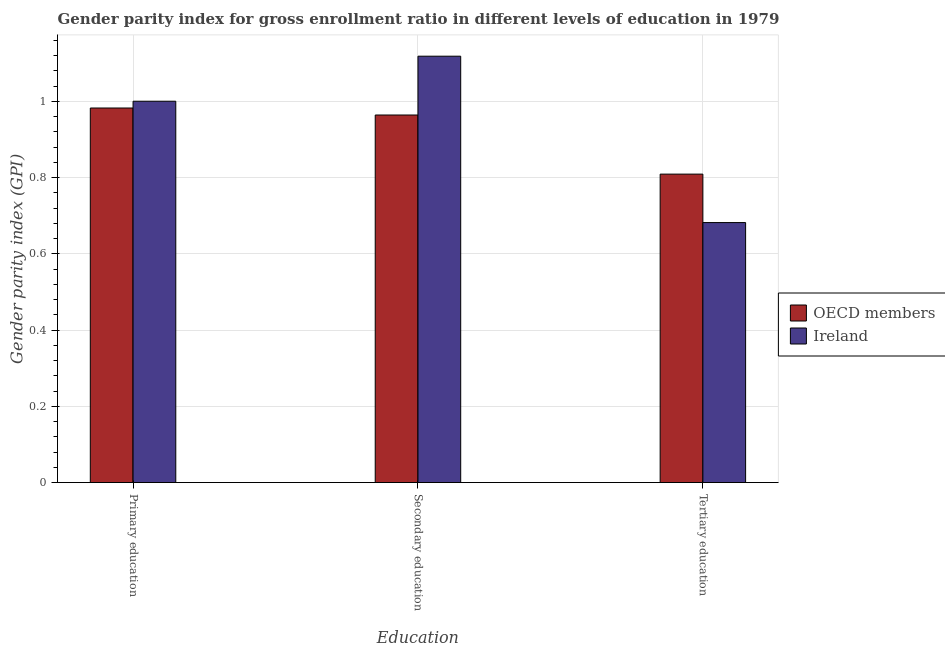Are the number of bars on each tick of the X-axis equal?
Give a very brief answer. Yes. How many bars are there on the 2nd tick from the right?
Provide a succinct answer. 2. What is the label of the 1st group of bars from the left?
Keep it short and to the point. Primary education. What is the gender parity index in tertiary education in Ireland?
Your response must be concise. 0.68. Across all countries, what is the maximum gender parity index in primary education?
Offer a terse response. 1. Across all countries, what is the minimum gender parity index in secondary education?
Provide a short and direct response. 0.96. In which country was the gender parity index in tertiary education maximum?
Give a very brief answer. OECD members. In which country was the gender parity index in secondary education minimum?
Keep it short and to the point. OECD members. What is the total gender parity index in primary education in the graph?
Offer a terse response. 1.98. What is the difference between the gender parity index in secondary education in Ireland and that in OECD members?
Your answer should be compact. 0.15. What is the difference between the gender parity index in primary education in Ireland and the gender parity index in tertiary education in OECD members?
Give a very brief answer. 0.19. What is the average gender parity index in secondary education per country?
Your answer should be compact. 1.04. What is the difference between the gender parity index in secondary education and gender parity index in tertiary education in OECD members?
Offer a very short reply. 0.16. In how many countries, is the gender parity index in secondary education greater than 0.7200000000000001 ?
Your answer should be compact. 2. What is the ratio of the gender parity index in secondary education in OECD members to that in Ireland?
Make the answer very short. 0.86. Is the gender parity index in tertiary education in OECD members less than that in Ireland?
Provide a short and direct response. No. What is the difference between the highest and the second highest gender parity index in primary education?
Your answer should be compact. 0.02. What is the difference between the highest and the lowest gender parity index in primary education?
Provide a succinct answer. 0.02. What does the 2nd bar from the left in Primary education represents?
Provide a short and direct response. Ireland. What does the 1st bar from the right in Primary education represents?
Provide a succinct answer. Ireland. Is it the case that in every country, the sum of the gender parity index in primary education and gender parity index in secondary education is greater than the gender parity index in tertiary education?
Make the answer very short. Yes. Are all the bars in the graph horizontal?
Your answer should be very brief. No. What is the difference between two consecutive major ticks on the Y-axis?
Provide a short and direct response. 0.2. Are the values on the major ticks of Y-axis written in scientific E-notation?
Ensure brevity in your answer.  No. Where does the legend appear in the graph?
Offer a terse response. Center right. How are the legend labels stacked?
Offer a very short reply. Vertical. What is the title of the graph?
Provide a succinct answer. Gender parity index for gross enrollment ratio in different levels of education in 1979. What is the label or title of the X-axis?
Your answer should be very brief. Education. What is the label or title of the Y-axis?
Provide a succinct answer. Gender parity index (GPI). What is the Gender parity index (GPI) in OECD members in Primary education?
Offer a very short reply. 0.98. What is the Gender parity index (GPI) of Ireland in Primary education?
Ensure brevity in your answer.  1. What is the Gender parity index (GPI) of OECD members in Secondary education?
Your answer should be very brief. 0.96. What is the Gender parity index (GPI) in Ireland in Secondary education?
Your answer should be very brief. 1.12. What is the Gender parity index (GPI) in OECD members in Tertiary education?
Ensure brevity in your answer.  0.81. What is the Gender parity index (GPI) of Ireland in Tertiary education?
Give a very brief answer. 0.68. Across all Education, what is the maximum Gender parity index (GPI) in OECD members?
Your answer should be compact. 0.98. Across all Education, what is the maximum Gender parity index (GPI) in Ireland?
Ensure brevity in your answer.  1.12. Across all Education, what is the minimum Gender parity index (GPI) of OECD members?
Make the answer very short. 0.81. Across all Education, what is the minimum Gender parity index (GPI) in Ireland?
Provide a succinct answer. 0.68. What is the total Gender parity index (GPI) of OECD members in the graph?
Provide a succinct answer. 2.76. What is the total Gender parity index (GPI) of Ireland in the graph?
Your answer should be compact. 2.8. What is the difference between the Gender parity index (GPI) in OECD members in Primary education and that in Secondary education?
Provide a succinct answer. 0.02. What is the difference between the Gender parity index (GPI) of Ireland in Primary education and that in Secondary education?
Make the answer very short. -0.12. What is the difference between the Gender parity index (GPI) of OECD members in Primary education and that in Tertiary education?
Offer a very short reply. 0.17. What is the difference between the Gender parity index (GPI) in Ireland in Primary education and that in Tertiary education?
Make the answer very short. 0.32. What is the difference between the Gender parity index (GPI) in OECD members in Secondary education and that in Tertiary education?
Ensure brevity in your answer.  0.15. What is the difference between the Gender parity index (GPI) of Ireland in Secondary education and that in Tertiary education?
Give a very brief answer. 0.44. What is the difference between the Gender parity index (GPI) in OECD members in Primary education and the Gender parity index (GPI) in Ireland in Secondary education?
Your answer should be very brief. -0.14. What is the difference between the Gender parity index (GPI) of OECD members in Primary education and the Gender parity index (GPI) of Ireland in Tertiary education?
Ensure brevity in your answer.  0.3. What is the difference between the Gender parity index (GPI) in OECD members in Secondary education and the Gender parity index (GPI) in Ireland in Tertiary education?
Offer a terse response. 0.28. What is the average Gender parity index (GPI) of OECD members per Education?
Provide a short and direct response. 0.92. What is the average Gender parity index (GPI) in Ireland per Education?
Your answer should be very brief. 0.93. What is the difference between the Gender parity index (GPI) in OECD members and Gender parity index (GPI) in Ireland in Primary education?
Provide a short and direct response. -0.02. What is the difference between the Gender parity index (GPI) in OECD members and Gender parity index (GPI) in Ireland in Secondary education?
Give a very brief answer. -0.15. What is the difference between the Gender parity index (GPI) in OECD members and Gender parity index (GPI) in Ireland in Tertiary education?
Make the answer very short. 0.13. What is the ratio of the Gender parity index (GPI) in Ireland in Primary education to that in Secondary education?
Make the answer very short. 0.89. What is the ratio of the Gender parity index (GPI) of OECD members in Primary education to that in Tertiary education?
Make the answer very short. 1.21. What is the ratio of the Gender parity index (GPI) in Ireland in Primary education to that in Tertiary education?
Your response must be concise. 1.47. What is the ratio of the Gender parity index (GPI) of OECD members in Secondary education to that in Tertiary education?
Make the answer very short. 1.19. What is the ratio of the Gender parity index (GPI) in Ireland in Secondary education to that in Tertiary education?
Ensure brevity in your answer.  1.64. What is the difference between the highest and the second highest Gender parity index (GPI) in OECD members?
Provide a succinct answer. 0.02. What is the difference between the highest and the second highest Gender parity index (GPI) in Ireland?
Offer a very short reply. 0.12. What is the difference between the highest and the lowest Gender parity index (GPI) of OECD members?
Offer a very short reply. 0.17. What is the difference between the highest and the lowest Gender parity index (GPI) in Ireland?
Ensure brevity in your answer.  0.44. 